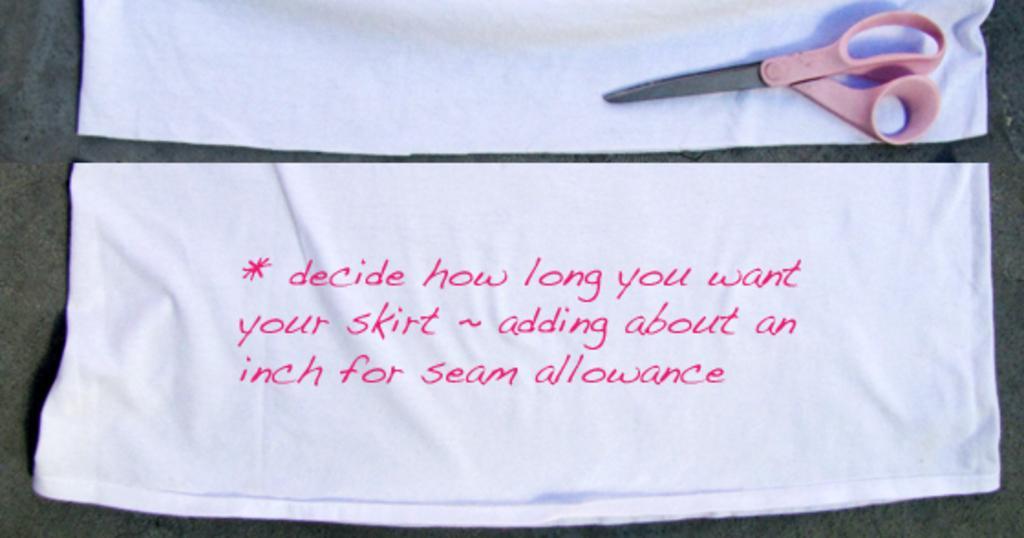In one or two sentences, can you explain what this image depicts? In this image we can see the text on the white cloth. We can also see a scissor on another white cloth and in the background, we can see the plain surface. 